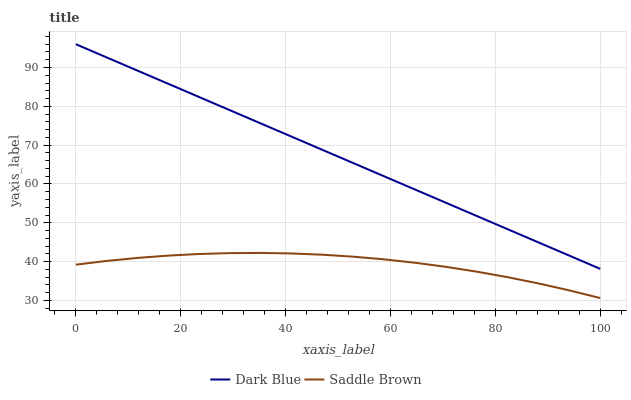Does Saddle Brown have the minimum area under the curve?
Answer yes or no. Yes. Does Dark Blue have the maximum area under the curve?
Answer yes or no. Yes. Does Saddle Brown have the maximum area under the curve?
Answer yes or no. No. Is Dark Blue the smoothest?
Answer yes or no. Yes. Is Saddle Brown the roughest?
Answer yes or no. Yes. Is Saddle Brown the smoothest?
Answer yes or no. No. Does Saddle Brown have the lowest value?
Answer yes or no. Yes. Does Dark Blue have the highest value?
Answer yes or no. Yes. Does Saddle Brown have the highest value?
Answer yes or no. No. Is Saddle Brown less than Dark Blue?
Answer yes or no. Yes. Is Dark Blue greater than Saddle Brown?
Answer yes or no. Yes. Does Saddle Brown intersect Dark Blue?
Answer yes or no. No. 